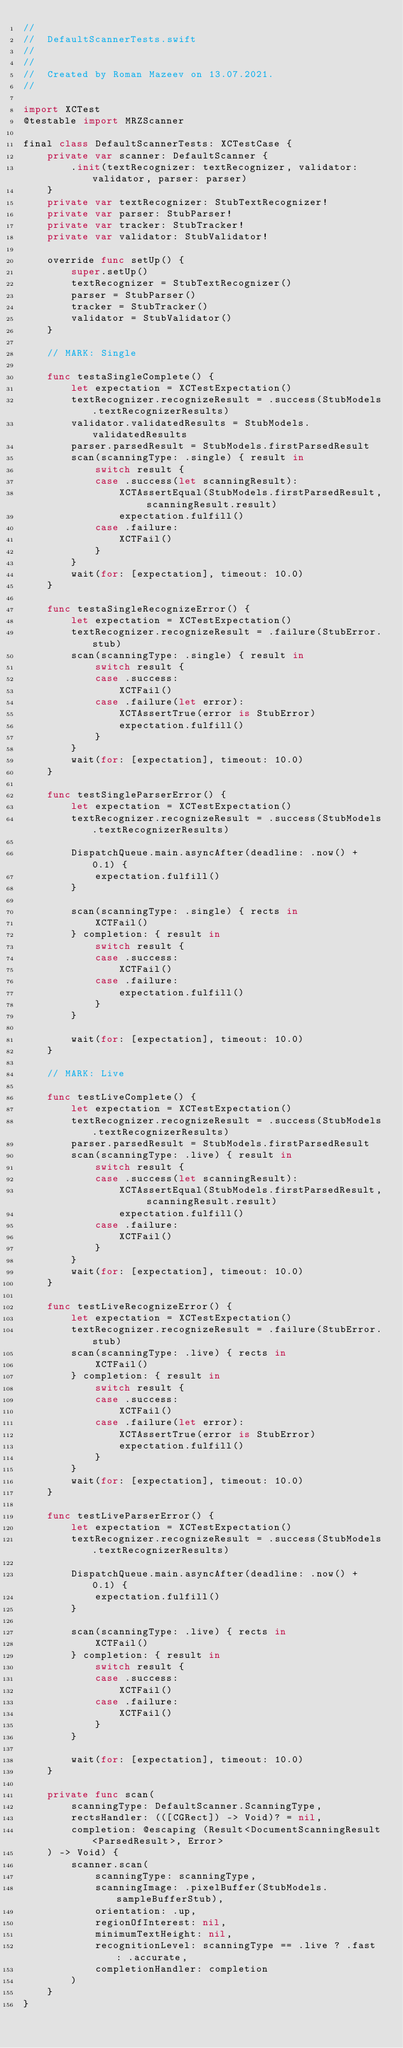<code> <loc_0><loc_0><loc_500><loc_500><_Swift_>//
//  DefaultScannerTests.swift
//  
//
//  Created by Roman Mazeev on 13.07.2021.
//

import XCTest
@testable import MRZScanner

final class DefaultScannerTests: XCTestCase {
    private var scanner: DefaultScanner {
        .init(textRecognizer: textRecognizer, validator: validator, parser: parser)
    }
    private var textRecognizer: StubTextRecognizer!
    private var parser: StubParser!
    private var tracker: StubTracker!
    private var validator: StubValidator!

    override func setUp() {
        super.setUp()
        textRecognizer = StubTextRecognizer()
        parser = StubParser()
        tracker = StubTracker()
        validator = StubValidator()
    }

    // MARK: Single

    func testaSingleComplete() {
        let expectation = XCTestExpectation()
        textRecognizer.recognizeResult = .success(StubModels.textRecognizerResults)
        validator.validatedResults = StubModels.validatedResults
        parser.parsedResult = StubModels.firstParsedResult
        scan(scanningType: .single) { result in
            switch result {
            case .success(let scanningResult):
                XCTAssertEqual(StubModels.firstParsedResult, scanningResult.result)
                expectation.fulfill()
            case .failure:
                XCTFail()
            }
        }
        wait(for: [expectation], timeout: 10.0)
    }

    func testaSingleRecognizeError() {
        let expectation = XCTestExpectation()
        textRecognizer.recognizeResult = .failure(StubError.stub)
        scan(scanningType: .single) { result in
            switch result {
            case .success:
                XCTFail()
            case .failure(let error):
                XCTAssertTrue(error is StubError)
                expectation.fulfill()
            }
        }
        wait(for: [expectation], timeout: 10.0)
    }

    func testSingleParserError() {
        let expectation = XCTestExpectation()
        textRecognizer.recognizeResult = .success(StubModels.textRecognizerResults)

        DispatchQueue.main.asyncAfter(deadline: .now() + 0.1) {
            expectation.fulfill()
        }

        scan(scanningType: .single) { rects in
            XCTFail()
        } completion: { result in
            switch result {
            case .success:
                XCTFail()
            case .failure:
                expectation.fulfill()
            }
        }

        wait(for: [expectation], timeout: 10.0)
    }

    // MARK: Live

    func testLiveComplete() {
        let expectation = XCTestExpectation()
        textRecognizer.recognizeResult = .success(StubModels.textRecognizerResults)
        parser.parsedResult = StubModels.firstParsedResult
        scan(scanningType: .live) { result in
            switch result {
            case .success(let scanningResult):
                XCTAssertEqual(StubModels.firstParsedResult, scanningResult.result)
                expectation.fulfill()
            case .failure:
                XCTFail()
            }
        }
        wait(for: [expectation], timeout: 10.0)
    }

    func testLiveRecognizeError() {
        let expectation = XCTestExpectation()
        textRecognizer.recognizeResult = .failure(StubError.stub)
        scan(scanningType: .live) { rects in
            XCTFail()
        } completion: { result in
            switch result {
            case .success:
                XCTFail()
            case .failure(let error):
                XCTAssertTrue(error is StubError)
                expectation.fulfill()
            }
        }
        wait(for: [expectation], timeout: 10.0)
    }

    func testLiveParserError() {
        let expectation = XCTestExpectation()
        textRecognizer.recognizeResult = .success(StubModels.textRecognizerResults)

        DispatchQueue.main.asyncAfter(deadline: .now() + 0.1) {
            expectation.fulfill()
        }

        scan(scanningType: .live) { rects in
            XCTFail()
        } completion: { result in
            switch result {
            case .success:
                XCTFail()
            case .failure:
                XCTFail()
            }
        }

        wait(for: [expectation], timeout: 10.0)
    }

    private func scan(
        scanningType: DefaultScanner.ScanningType,
        rectsHandler: (([CGRect]) -> Void)? = nil,
        completion: @escaping (Result<DocumentScanningResult<ParsedResult>, Error>
    ) -> Void) {
        scanner.scan(
            scanningType: scanningType,
            scanningImage: .pixelBuffer(StubModels.sampleBufferStub),
            orientation: .up,
            regionOfInterest: nil,
            minimumTextHeight: nil,
            recognitionLevel: scanningType == .live ? .fast : .accurate,
            completionHandler: completion
        )
    }
}
</code> 